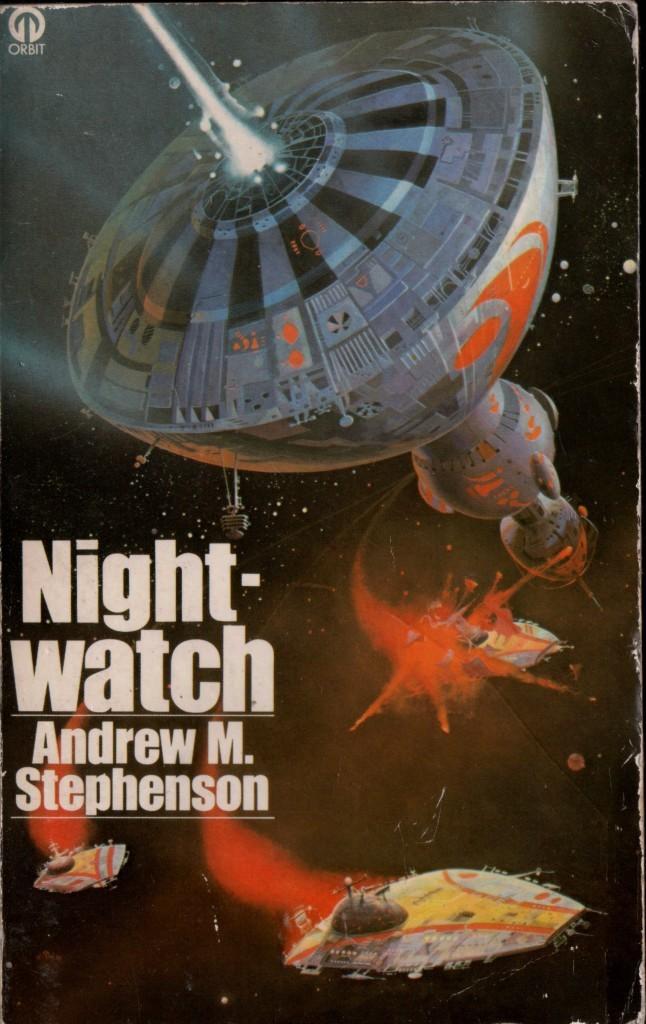Who wrote the novel?
Your response must be concise. Andrew m. stephenson. 